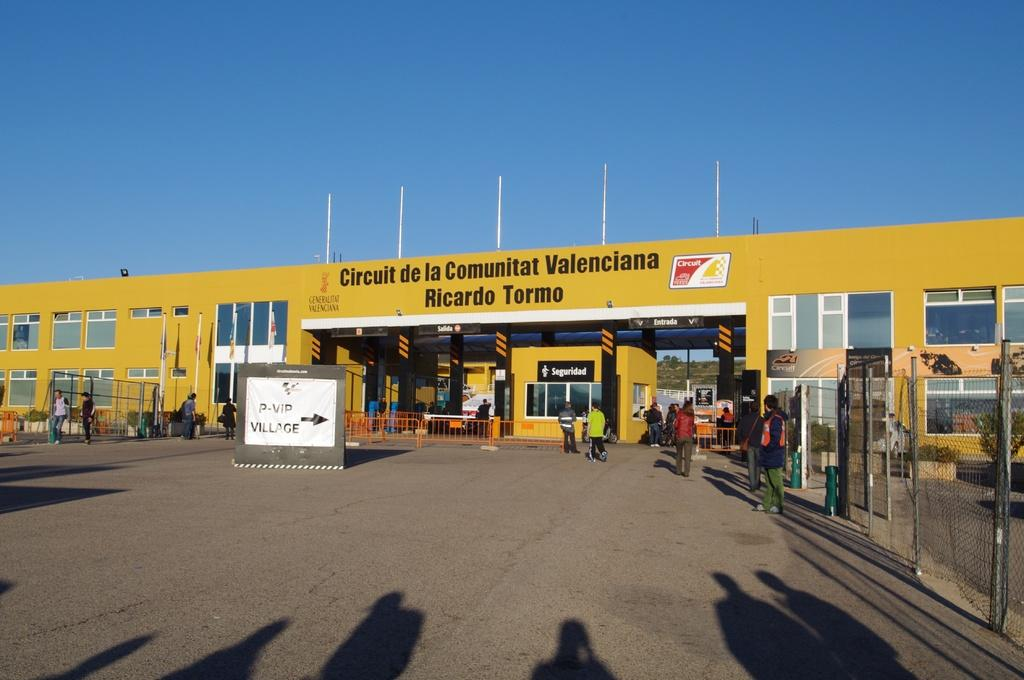<image>
Summarize the visual content of the image. A yellow building with the words Circuit de la Communitat Valenciana on it 